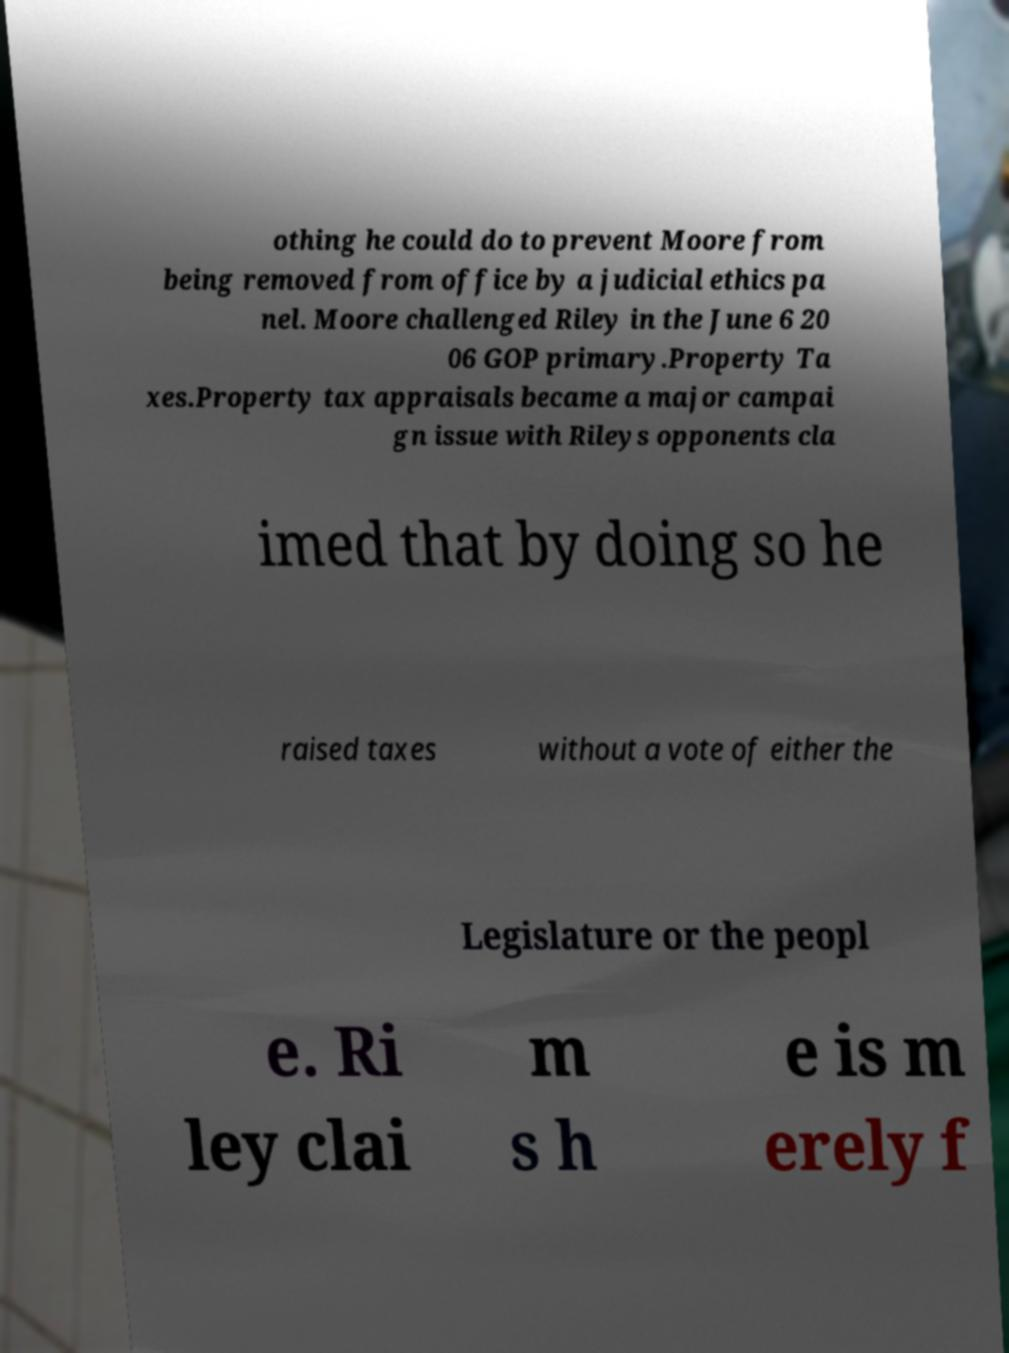What messages or text are displayed in this image? I need them in a readable, typed format. othing he could do to prevent Moore from being removed from office by a judicial ethics pa nel. Moore challenged Riley in the June 6 20 06 GOP primary.Property Ta xes.Property tax appraisals became a major campai gn issue with Rileys opponents cla imed that by doing so he raised taxes without a vote of either the Legislature or the peopl e. Ri ley clai m s h e is m erely f 